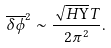Convert formula to latex. <formula><loc_0><loc_0><loc_500><loc_500>\overline { \delta \phi } ^ { 2 } \sim \frac { \sqrt { H \Upsilon } T } { 2 \pi ^ { 2 } } .</formula> 